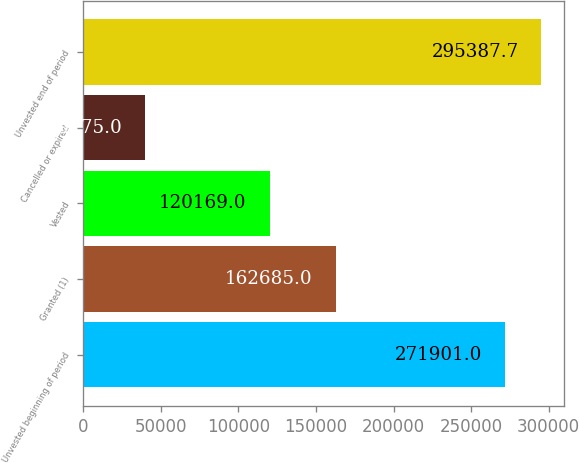<chart> <loc_0><loc_0><loc_500><loc_500><bar_chart><fcel>Unvested beginning of period<fcel>Granted (1)<fcel>Vested<fcel>Cancelled or expired<fcel>Unvested end of period<nl><fcel>271901<fcel>162685<fcel>120169<fcel>39775<fcel>295388<nl></chart> 